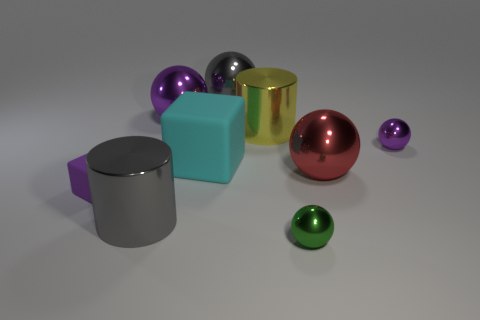Subtract all green spheres. How many spheres are left? 4 Subtract all green cylinders. Subtract all yellow spheres. How many cylinders are left? 2 Subtract all blocks. How many objects are left? 7 Add 3 large gray metal balls. How many large gray metal balls are left? 4 Add 2 gray spheres. How many gray spheres exist? 3 Subtract 0 red blocks. How many objects are left? 9 Subtract all big metal cylinders. Subtract all purple things. How many objects are left? 4 